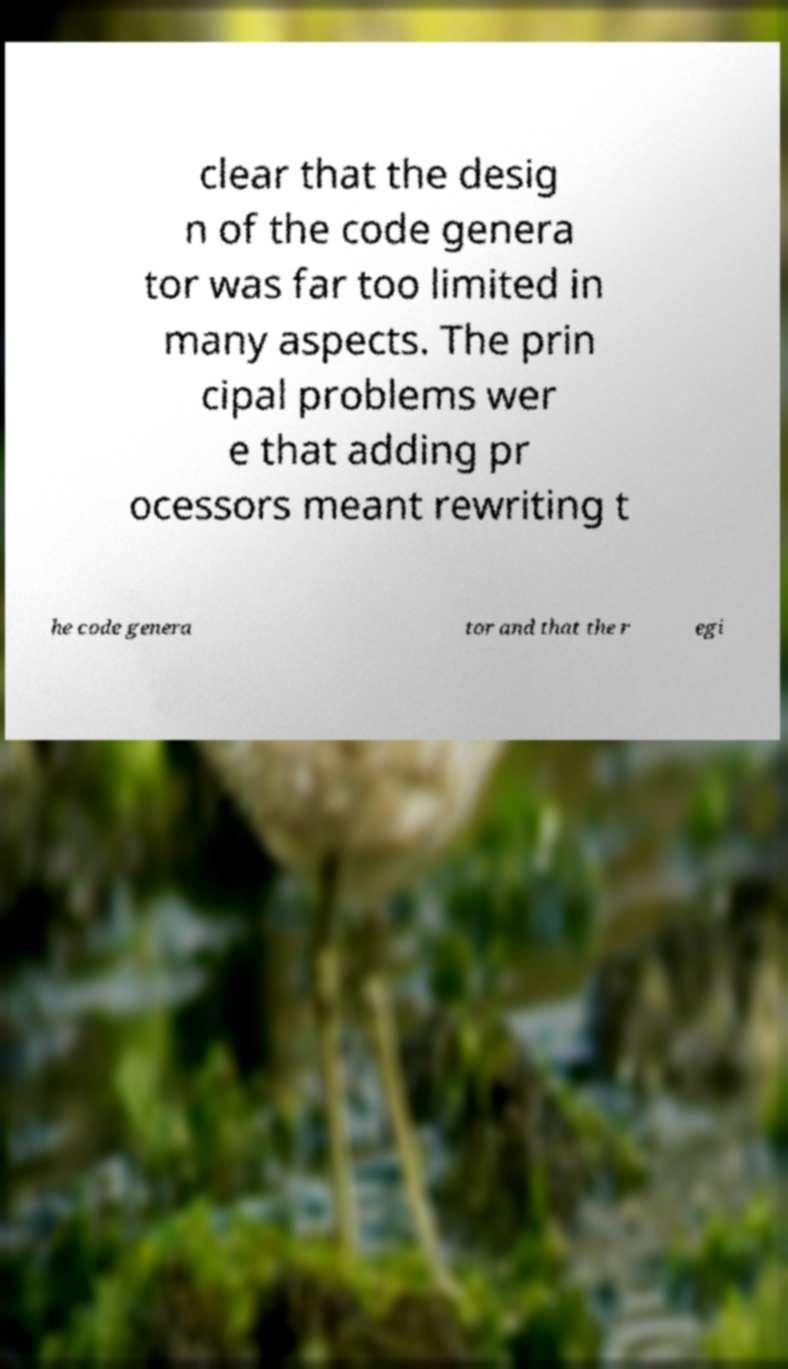Could you assist in decoding the text presented in this image and type it out clearly? clear that the desig n of the code genera tor was far too limited in many aspects. The prin cipal problems wer e that adding pr ocessors meant rewriting t he code genera tor and that the r egi 